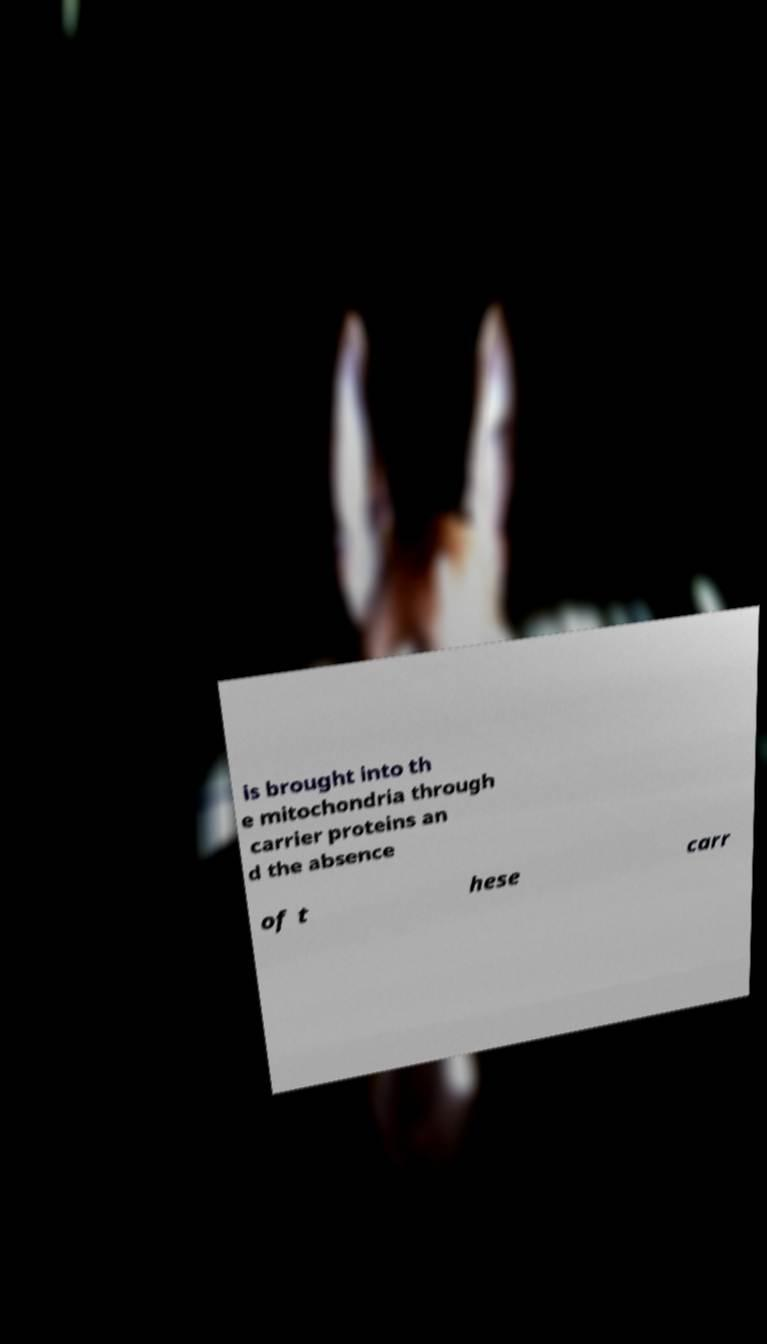Can you accurately transcribe the text from the provided image for me? is brought into th e mitochondria through carrier proteins an d the absence of t hese carr 